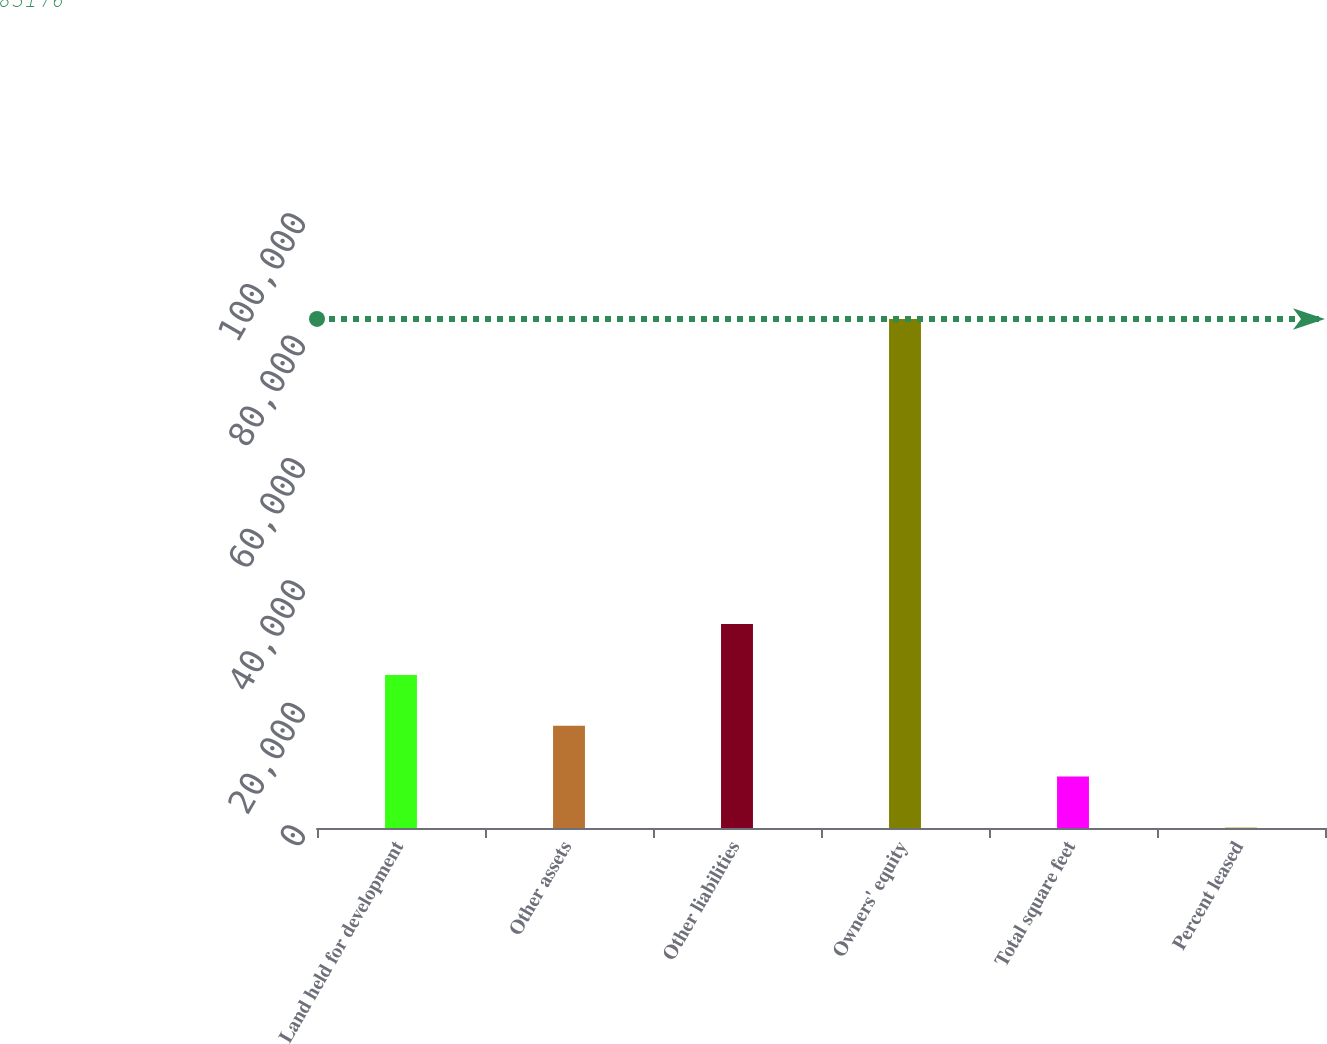<chart> <loc_0><loc_0><loc_500><loc_500><bar_chart><fcel>Land held for development<fcel>Other assets<fcel>Other liabilities<fcel>Owners' equity<fcel>Total square feet<fcel>Percent leased<nl><fcel>25018.7<fcel>16710.6<fcel>33326.9<fcel>83176<fcel>8402.38<fcel>94.2<nl></chart> 